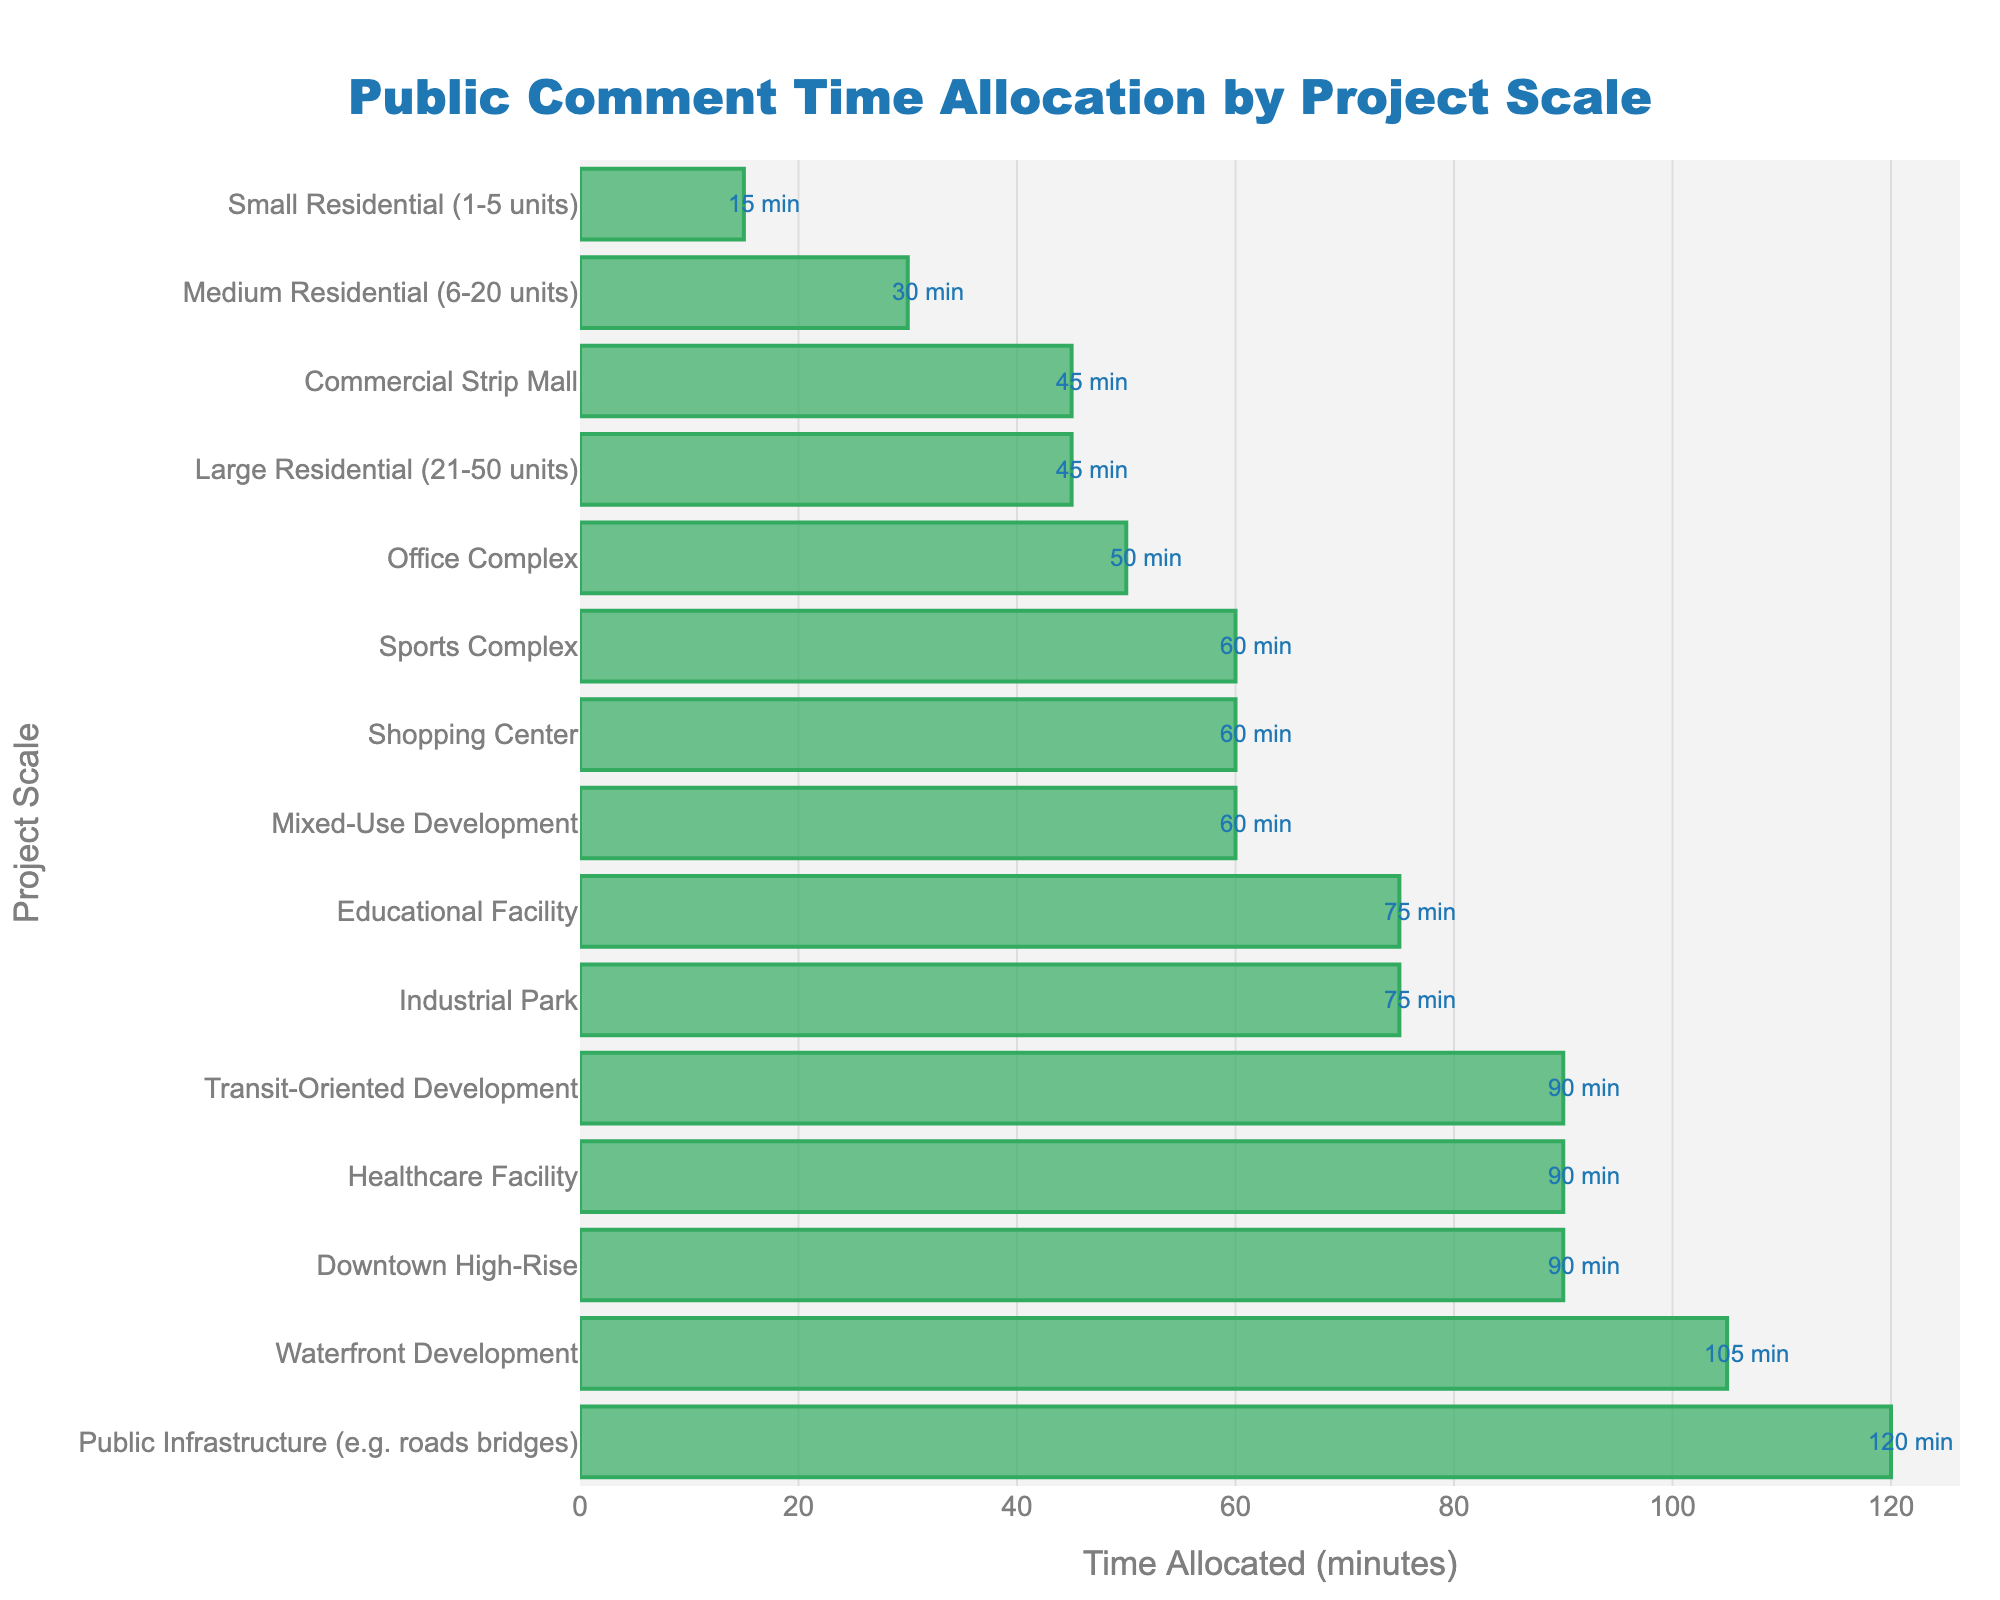What project scale allocates the most time for public comments? The "Public Infrastructure" project scale allocates 120 minutes for public comments, which is the highest among all the categories listed in the figure.
Answer: Public Infrastructure Which project scale allocates the least time for public comments? The "Small Residential (1-5 units)" project scale allocates only 15 minutes for public comments, which is the lowest among all categories.
Answer: Small Residential (1-5 units) How much more time is allocated for public comments in a "Healthcare Facility" compared to a "Small Residential (1-5 units)" project? The Healthcare Facility allocates 90 minutes while Small Residential allocates 15 minutes. The difference is 90 - 15 = 75 minutes.
Answer: 75 minutes What is the average time allocated for public comments across all project scales? Add up all the time allocated (15 + 30 + 45 + 60 + 45 + 50 + 75 + 90 + 60 + 120 + 75 + 90 + 60 + 105 + 90 = 1010 minutes) and divide by the number of project scales (15). The average time allocated is 1010 / 15 = 67.33 minutes.
Answer: 67.33 minutes Compare the time allocated for public comments between "Mixed-Use Development" and "Commercial Strip Mall." Which one has more and by how much? Mixed-Use Development allocates 60 minutes while Commercial Strip Mall allocates 45 minutes. The difference is 60 - 45 = 15 minutes.
Answer: Mixed-Use Development by 15 minutes Is the time allocated for public comments in an "Industrial Park" project more than in an "Office Complex" project? The Industrial Park allocates 75 minutes for public comments, whereas the Office Complex allocates 50 minutes. 75 minutes is greater than 50 minutes.
Answer: Yes What proportion of the total allocated time does the "Downtown High-Rise" project represent? The total allocated time is 1010 minutes. The "Downtown High-Rise" project allocates 90 minutes. The proportion is 90 / 1010 ≈ 0.0891 or about 8.91%.
Answer: 8.91% Which project scales allocate exactly 60 minutes for public comments? By inspecting the figure, the projects that allocate exactly 60 minutes are Mixed-Use Development, Shopping Center, Sports Complex, and Transit-Oriented Development.
Answer: Mixed-Use Development, Shopping Center, Sports Complex, Transit-Oriented Development Are there more project scales that allocate less than, equal to, or more than 60 minutes for public comments? Count the project scales based on the time allocated:
- Less than 60 minutes: Small Residential (15), Medium Residential (30), Large Residential (45), Commercial Strip Mall (45), Office Complex (50)
- Equal to 60 minutes: Mixed-Use Development, Shopping Center, Sports Complex, Transit-Oriented Development
- More than 60 minutes: Industrial Park (75), Educational Facility (75), Healthcare Facility (90), Downtown High-Rise (90), Waterfront Development (105), Public Infrastructure (120)
By counting, 5 scales allocate less than 60 minutes, 4 allocate exactly 60 minutes, and 6 allocate more than 60 minutes.
Answer: More than 60 minutes What's the range of time allocated for public comments across all project scales? The range is the difference between the maximum and minimum values. The maximum time allocated is 120 minutes (Public Infrastructure) and the minimum is 15 minutes (Small Residential). The range is 120 - 15 = 105 minutes.
Answer: 105 minutes 